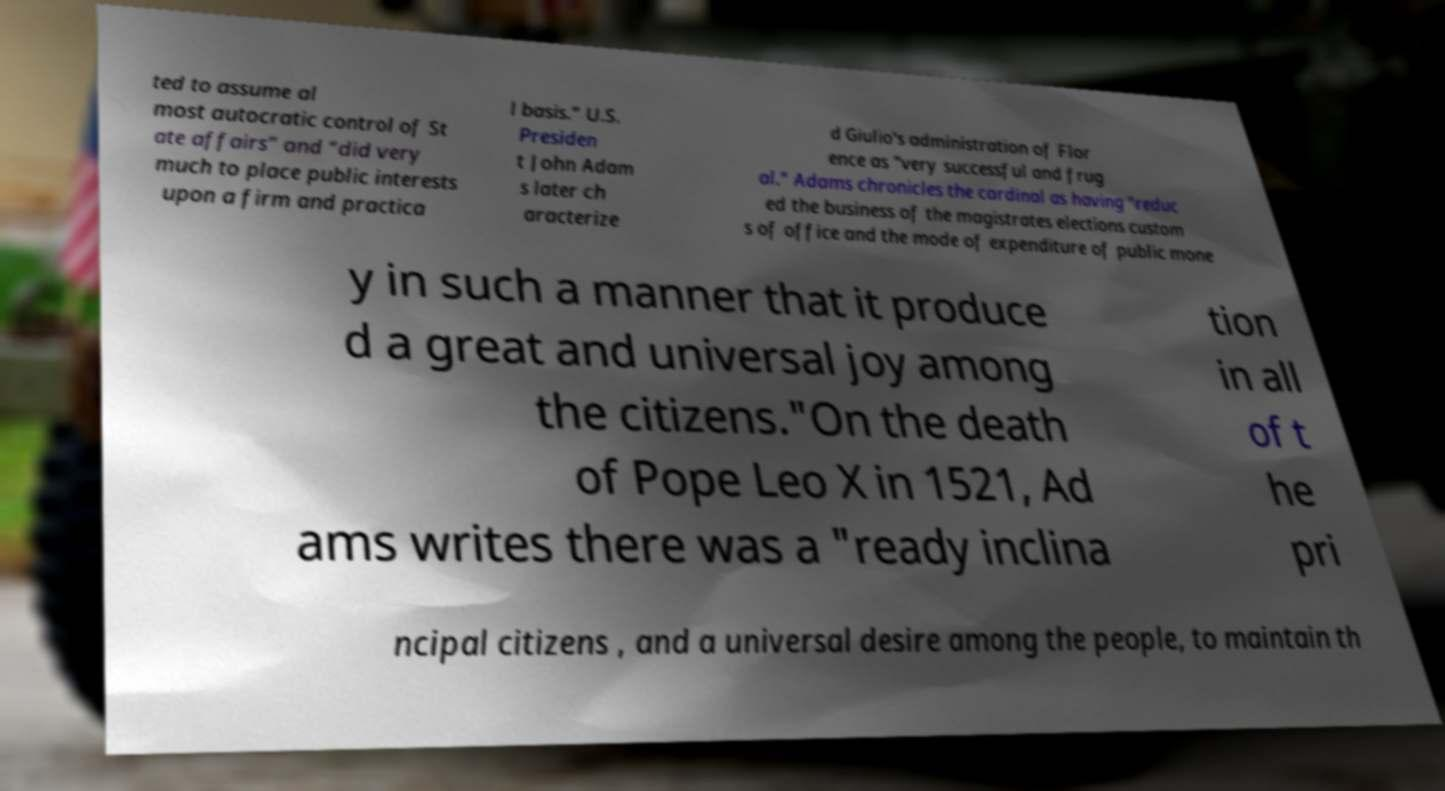What messages or text are displayed in this image? I need them in a readable, typed format. ted to assume al most autocratic control of St ate affairs” and “did very much to place public interests upon a firm and practica l basis.” U.S. Presiden t John Adam s later ch aracterize d Giulio's administration of Flor ence as "very successful and frug al." Adams chronicles the cardinal as having "reduc ed the business of the magistrates elections custom s of office and the mode of expenditure of public mone y in such a manner that it produce d a great and universal joy among the citizens."On the death of Pope Leo X in 1521, Ad ams writes there was a "ready inclina tion in all of t he pri ncipal citizens , and a universal desire among the people, to maintain th 